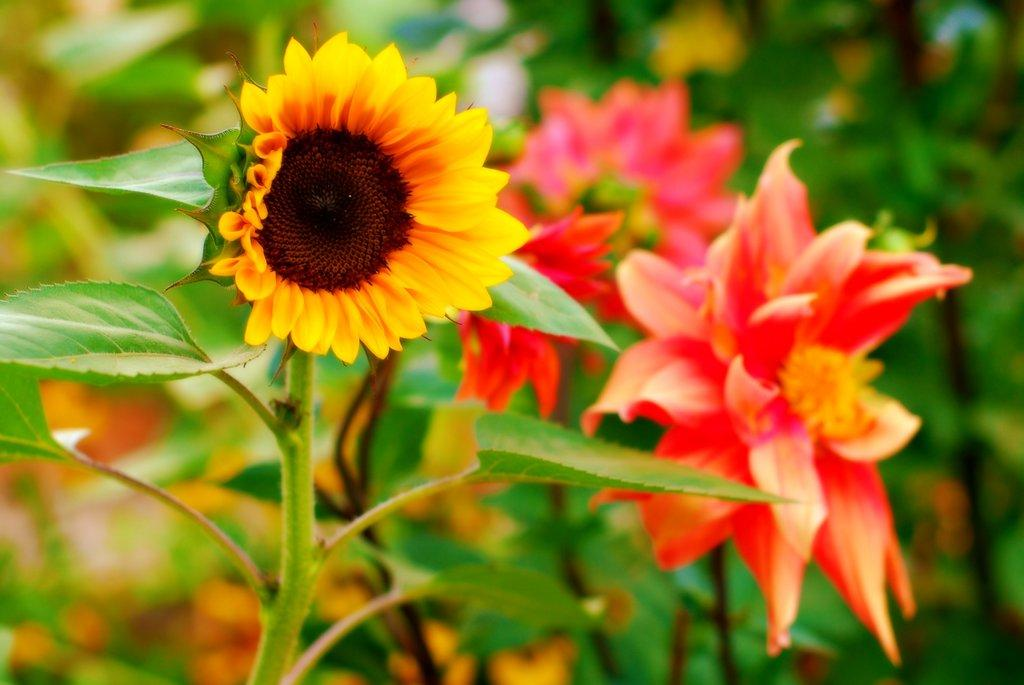What is present in the image? There is a plant in the image. What can be observed about the plant? The plant has flowers. What colors are the flowers? The flowers are in yellow and orange colors. Can you see any bats flying around the plant in the image? There are no bats present in the image; it only features a plant with yellow and orange flowers. 